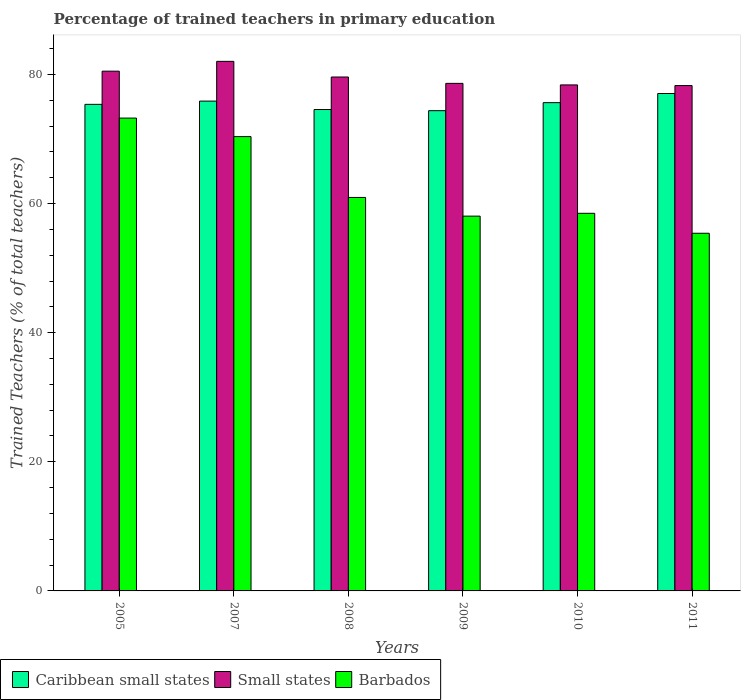How many different coloured bars are there?
Give a very brief answer. 3. How many groups of bars are there?
Keep it short and to the point. 6. Are the number of bars per tick equal to the number of legend labels?
Give a very brief answer. Yes. Are the number of bars on each tick of the X-axis equal?
Your answer should be very brief. Yes. How many bars are there on the 6th tick from the left?
Provide a short and direct response. 3. In how many cases, is the number of bars for a given year not equal to the number of legend labels?
Keep it short and to the point. 0. What is the percentage of trained teachers in Barbados in 2005?
Your answer should be compact. 73.25. Across all years, what is the maximum percentage of trained teachers in Caribbean small states?
Provide a succinct answer. 77.06. Across all years, what is the minimum percentage of trained teachers in Small states?
Keep it short and to the point. 78.28. In which year was the percentage of trained teachers in Barbados maximum?
Provide a succinct answer. 2005. In which year was the percentage of trained teachers in Caribbean small states minimum?
Provide a succinct answer. 2009. What is the total percentage of trained teachers in Caribbean small states in the graph?
Provide a short and direct response. 452.92. What is the difference between the percentage of trained teachers in Small states in 2007 and that in 2009?
Provide a succinct answer. 3.41. What is the difference between the percentage of trained teachers in Barbados in 2005 and the percentage of trained teachers in Small states in 2009?
Your response must be concise. -5.38. What is the average percentage of trained teachers in Caribbean small states per year?
Make the answer very short. 75.49. In the year 2010, what is the difference between the percentage of trained teachers in Barbados and percentage of trained teachers in Caribbean small states?
Give a very brief answer. -17.14. In how many years, is the percentage of trained teachers in Small states greater than 20 %?
Make the answer very short. 6. What is the ratio of the percentage of trained teachers in Caribbean small states in 2005 to that in 2009?
Your answer should be compact. 1.01. Is the difference between the percentage of trained teachers in Barbados in 2007 and 2008 greater than the difference between the percentage of trained teachers in Caribbean small states in 2007 and 2008?
Your answer should be compact. Yes. What is the difference between the highest and the second highest percentage of trained teachers in Caribbean small states?
Your answer should be very brief. 1.18. What is the difference between the highest and the lowest percentage of trained teachers in Barbados?
Provide a succinct answer. 17.84. What does the 1st bar from the left in 2007 represents?
Your answer should be very brief. Caribbean small states. What does the 3rd bar from the right in 2009 represents?
Provide a succinct answer. Caribbean small states. Is it the case that in every year, the sum of the percentage of trained teachers in Small states and percentage of trained teachers in Barbados is greater than the percentage of trained teachers in Caribbean small states?
Your response must be concise. Yes. Are the values on the major ticks of Y-axis written in scientific E-notation?
Keep it short and to the point. No. Does the graph contain any zero values?
Ensure brevity in your answer.  No. Does the graph contain grids?
Your answer should be very brief. No. How many legend labels are there?
Make the answer very short. 3. How are the legend labels stacked?
Keep it short and to the point. Horizontal. What is the title of the graph?
Give a very brief answer. Percentage of trained teachers in primary education. What is the label or title of the X-axis?
Provide a short and direct response. Years. What is the label or title of the Y-axis?
Offer a terse response. Trained Teachers (% of total teachers). What is the Trained Teachers (% of total teachers) of Caribbean small states in 2005?
Give a very brief answer. 75.38. What is the Trained Teachers (% of total teachers) in Small states in 2005?
Ensure brevity in your answer.  80.51. What is the Trained Teachers (% of total teachers) in Barbados in 2005?
Offer a terse response. 73.25. What is the Trained Teachers (% of total teachers) in Caribbean small states in 2007?
Provide a short and direct response. 75.88. What is the Trained Teachers (% of total teachers) of Small states in 2007?
Make the answer very short. 82.04. What is the Trained Teachers (% of total teachers) of Barbados in 2007?
Provide a succinct answer. 70.38. What is the Trained Teachers (% of total teachers) of Caribbean small states in 2008?
Give a very brief answer. 74.57. What is the Trained Teachers (% of total teachers) of Small states in 2008?
Provide a short and direct response. 79.61. What is the Trained Teachers (% of total teachers) of Barbados in 2008?
Keep it short and to the point. 60.95. What is the Trained Teachers (% of total teachers) in Caribbean small states in 2009?
Your answer should be compact. 74.39. What is the Trained Teachers (% of total teachers) of Small states in 2009?
Keep it short and to the point. 78.63. What is the Trained Teachers (% of total teachers) in Barbados in 2009?
Make the answer very short. 58.06. What is the Trained Teachers (% of total teachers) in Caribbean small states in 2010?
Provide a succinct answer. 75.64. What is the Trained Teachers (% of total teachers) of Small states in 2010?
Provide a succinct answer. 78.39. What is the Trained Teachers (% of total teachers) of Barbados in 2010?
Offer a very short reply. 58.5. What is the Trained Teachers (% of total teachers) in Caribbean small states in 2011?
Make the answer very short. 77.06. What is the Trained Teachers (% of total teachers) of Small states in 2011?
Offer a terse response. 78.28. What is the Trained Teachers (% of total teachers) of Barbados in 2011?
Your response must be concise. 55.41. Across all years, what is the maximum Trained Teachers (% of total teachers) of Caribbean small states?
Provide a short and direct response. 77.06. Across all years, what is the maximum Trained Teachers (% of total teachers) in Small states?
Offer a very short reply. 82.04. Across all years, what is the maximum Trained Teachers (% of total teachers) in Barbados?
Give a very brief answer. 73.25. Across all years, what is the minimum Trained Teachers (% of total teachers) of Caribbean small states?
Provide a succinct answer. 74.39. Across all years, what is the minimum Trained Teachers (% of total teachers) of Small states?
Your answer should be compact. 78.28. Across all years, what is the minimum Trained Teachers (% of total teachers) of Barbados?
Keep it short and to the point. 55.41. What is the total Trained Teachers (% of total teachers) in Caribbean small states in the graph?
Keep it short and to the point. 452.92. What is the total Trained Teachers (% of total teachers) in Small states in the graph?
Keep it short and to the point. 477.46. What is the total Trained Teachers (% of total teachers) in Barbados in the graph?
Provide a short and direct response. 376.54. What is the difference between the Trained Teachers (% of total teachers) of Caribbean small states in 2005 and that in 2007?
Provide a short and direct response. -0.5. What is the difference between the Trained Teachers (% of total teachers) in Small states in 2005 and that in 2007?
Your answer should be very brief. -1.52. What is the difference between the Trained Teachers (% of total teachers) of Barbados in 2005 and that in 2007?
Give a very brief answer. 2.87. What is the difference between the Trained Teachers (% of total teachers) of Caribbean small states in 2005 and that in 2008?
Ensure brevity in your answer.  0.8. What is the difference between the Trained Teachers (% of total teachers) in Small states in 2005 and that in 2008?
Keep it short and to the point. 0.91. What is the difference between the Trained Teachers (% of total teachers) of Barbados in 2005 and that in 2008?
Your answer should be very brief. 12.29. What is the difference between the Trained Teachers (% of total teachers) of Caribbean small states in 2005 and that in 2009?
Give a very brief answer. 0.98. What is the difference between the Trained Teachers (% of total teachers) in Small states in 2005 and that in 2009?
Make the answer very short. 1.89. What is the difference between the Trained Teachers (% of total teachers) in Barbados in 2005 and that in 2009?
Offer a very short reply. 15.19. What is the difference between the Trained Teachers (% of total teachers) in Caribbean small states in 2005 and that in 2010?
Provide a succinct answer. -0.26. What is the difference between the Trained Teachers (% of total teachers) in Small states in 2005 and that in 2010?
Make the answer very short. 2.13. What is the difference between the Trained Teachers (% of total teachers) of Barbados in 2005 and that in 2010?
Offer a terse response. 14.75. What is the difference between the Trained Teachers (% of total teachers) of Caribbean small states in 2005 and that in 2011?
Provide a succinct answer. -1.68. What is the difference between the Trained Teachers (% of total teachers) of Small states in 2005 and that in 2011?
Provide a short and direct response. 2.23. What is the difference between the Trained Teachers (% of total teachers) in Barbados in 2005 and that in 2011?
Your answer should be compact. 17.84. What is the difference between the Trained Teachers (% of total teachers) of Caribbean small states in 2007 and that in 2008?
Ensure brevity in your answer.  1.3. What is the difference between the Trained Teachers (% of total teachers) of Small states in 2007 and that in 2008?
Make the answer very short. 2.43. What is the difference between the Trained Teachers (% of total teachers) of Barbados in 2007 and that in 2008?
Your answer should be very brief. 9.43. What is the difference between the Trained Teachers (% of total teachers) of Caribbean small states in 2007 and that in 2009?
Offer a very short reply. 1.48. What is the difference between the Trained Teachers (% of total teachers) of Small states in 2007 and that in 2009?
Ensure brevity in your answer.  3.41. What is the difference between the Trained Teachers (% of total teachers) in Barbados in 2007 and that in 2009?
Your response must be concise. 12.32. What is the difference between the Trained Teachers (% of total teachers) in Caribbean small states in 2007 and that in 2010?
Ensure brevity in your answer.  0.24. What is the difference between the Trained Teachers (% of total teachers) in Small states in 2007 and that in 2010?
Keep it short and to the point. 3.65. What is the difference between the Trained Teachers (% of total teachers) in Barbados in 2007 and that in 2010?
Offer a very short reply. 11.88. What is the difference between the Trained Teachers (% of total teachers) in Caribbean small states in 2007 and that in 2011?
Offer a very short reply. -1.18. What is the difference between the Trained Teachers (% of total teachers) of Small states in 2007 and that in 2011?
Provide a short and direct response. 3.75. What is the difference between the Trained Teachers (% of total teachers) of Barbados in 2007 and that in 2011?
Your answer should be compact. 14.97. What is the difference between the Trained Teachers (% of total teachers) in Caribbean small states in 2008 and that in 2009?
Make the answer very short. 0.18. What is the difference between the Trained Teachers (% of total teachers) of Small states in 2008 and that in 2009?
Provide a succinct answer. 0.98. What is the difference between the Trained Teachers (% of total teachers) in Barbados in 2008 and that in 2009?
Ensure brevity in your answer.  2.9. What is the difference between the Trained Teachers (% of total teachers) in Caribbean small states in 2008 and that in 2010?
Your response must be concise. -1.06. What is the difference between the Trained Teachers (% of total teachers) of Small states in 2008 and that in 2010?
Provide a short and direct response. 1.22. What is the difference between the Trained Teachers (% of total teachers) in Barbados in 2008 and that in 2010?
Keep it short and to the point. 2.46. What is the difference between the Trained Teachers (% of total teachers) in Caribbean small states in 2008 and that in 2011?
Offer a very short reply. -2.48. What is the difference between the Trained Teachers (% of total teachers) of Small states in 2008 and that in 2011?
Offer a very short reply. 1.33. What is the difference between the Trained Teachers (% of total teachers) of Barbados in 2008 and that in 2011?
Give a very brief answer. 5.55. What is the difference between the Trained Teachers (% of total teachers) of Caribbean small states in 2009 and that in 2010?
Provide a succinct answer. -1.25. What is the difference between the Trained Teachers (% of total teachers) of Small states in 2009 and that in 2010?
Your response must be concise. 0.24. What is the difference between the Trained Teachers (% of total teachers) in Barbados in 2009 and that in 2010?
Offer a terse response. -0.44. What is the difference between the Trained Teachers (% of total teachers) in Caribbean small states in 2009 and that in 2011?
Ensure brevity in your answer.  -2.66. What is the difference between the Trained Teachers (% of total teachers) of Small states in 2009 and that in 2011?
Provide a short and direct response. 0.34. What is the difference between the Trained Teachers (% of total teachers) in Barbados in 2009 and that in 2011?
Keep it short and to the point. 2.65. What is the difference between the Trained Teachers (% of total teachers) in Caribbean small states in 2010 and that in 2011?
Your answer should be very brief. -1.42. What is the difference between the Trained Teachers (% of total teachers) in Small states in 2010 and that in 2011?
Keep it short and to the point. 0.1. What is the difference between the Trained Teachers (% of total teachers) in Barbados in 2010 and that in 2011?
Offer a very short reply. 3.09. What is the difference between the Trained Teachers (% of total teachers) in Caribbean small states in 2005 and the Trained Teachers (% of total teachers) in Small states in 2007?
Keep it short and to the point. -6.66. What is the difference between the Trained Teachers (% of total teachers) of Caribbean small states in 2005 and the Trained Teachers (% of total teachers) of Barbados in 2007?
Provide a short and direct response. 5. What is the difference between the Trained Teachers (% of total teachers) in Small states in 2005 and the Trained Teachers (% of total teachers) in Barbados in 2007?
Provide a succinct answer. 10.13. What is the difference between the Trained Teachers (% of total teachers) in Caribbean small states in 2005 and the Trained Teachers (% of total teachers) in Small states in 2008?
Make the answer very short. -4.23. What is the difference between the Trained Teachers (% of total teachers) of Caribbean small states in 2005 and the Trained Teachers (% of total teachers) of Barbados in 2008?
Your answer should be very brief. 14.42. What is the difference between the Trained Teachers (% of total teachers) of Small states in 2005 and the Trained Teachers (% of total teachers) of Barbados in 2008?
Provide a succinct answer. 19.56. What is the difference between the Trained Teachers (% of total teachers) of Caribbean small states in 2005 and the Trained Teachers (% of total teachers) of Small states in 2009?
Offer a terse response. -3.25. What is the difference between the Trained Teachers (% of total teachers) in Caribbean small states in 2005 and the Trained Teachers (% of total teachers) in Barbados in 2009?
Ensure brevity in your answer.  17.32. What is the difference between the Trained Teachers (% of total teachers) in Small states in 2005 and the Trained Teachers (% of total teachers) in Barbados in 2009?
Provide a succinct answer. 22.46. What is the difference between the Trained Teachers (% of total teachers) of Caribbean small states in 2005 and the Trained Teachers (% of total teachers) of Small states in 2010?
Provide a short and direct response. -3.01. What is the difference between the Trained Teachers (% of total teachers) in Caribbean small states in 2005 and the Trained Teachers (% of total teachers) in Barbados in 2010?
Give a very brief answer. 16.88. What is the difference between the Trained Teachers (% of total teachers) of Small states in 2005 and the Trained Teachers (% of total teachers) of Barbados in 2010?
Keep it short and to the point. 22.02. What is the difference between the Trained Teachers (% of total teachers) in Caribbean small states in 2005 and the Trained Teachers (% of total teachers) in Small states in 2011?
Keep it short and to the point. -2.91. What is the difference between the Trained Teachers (% of total teachers) of Caribbean small states in 2005 and the Trained Teachers (% of total teachers) of Barbados in 2011?
Give a very brief answer. 19.97. What is the difference between the Trained Teachers (% of total teachers) of Small states in 2005 and the Trained Teachers (% of total teachers) of Barbados in 2011?
Ensure brevity in your answer.  25.11. What is the difference between the Trained Teachers (% of total teachers) of Caribbean small states in 2007 and the Trained Teachers (% of total teachers) of Small states in 2008?
Make the answer very short. -3.73. What is the difference between the Trained Teachers (% of total teachers) of Caribbean small states in 2007 and the Trained Teachers (% of total teachers) of Barbados in 2008?
Provide a succinct answer. 14.92. What is the difference between the Trained Teachers (% of total teachers) of Small states in 2007 and the Trained Teachers (% of total teachers) of Barbados in 2008?
Provide a short and direct response. 21.08. What is the difference between the Trained Teachers (% of total teachers) in Caribbean small states in 2007 and the Trained Teachers (% of total teachers) in Small states in 2009?
Provide a succinct answer. -2.75. What is the difference between the Trained Teachers (% of total teachers) of Caribbean small states in 2007 and the Trained Teachers (% of total teachers) of Barbados in 2009?
Give a very brief answer. 17.82. What is the difference between the Trained Teachers (% of total teachers) in Small states in 2007 and the Trained Teachers (% of total teachers) in Barbados in 2009?
Offer a terse response. 23.98. What is the difference between the Trained Teachers (% of total teachers) in Caribbean small states in 2007 and the Trained Teachers (% of total teachers) in Small states in 2010?
Provide a succinct answer. -2.51. What is the difference between the Trained Teachers (% of total teachers) in Caribbean small states in 2007 and the Trained Teachers (% of total teachers) in Barbados in 2010?
Make the answer very short. 17.38. What is the difference between the Trained Teachers (% of total teachers) of Small states in 2007 and the Trained Teachers (% of total teachers) of Barbados in 2010?
Keep it short and to the point. 23.54. What is the difference between the Trained Teachers (% of total teachers) of Caribbean small states in 2007 and the Trained Teachers (% of total teachers) of Small states in 2011?
Provide a succinct answer. -2.41. What is the difference between the Trained Teachers (% of total teachers) in Caribbean small states in 2007 and the Trained Teachers (% of total teachers) in Barbados in 2011?
Offer a terse response. 20.47. What is the difference between the Trained Teachers (% of total teachers) of Small states in 2007 and the Trained Teachers (% of total teachers) of Barbados in 2011?
Offer a very short reply. 26.63. What is the difference between the Trained Teachers (% of total teachers) in Caribbean small states in 2008 and the Trained Teachers (% of total teachers) in Small states in 2009?
Provide a succinct answer. -4.05. What is the difference between the Trained Teachers (% of total teachers) of Caribbean small states in 2008 and the Trained Teachers (% of total teachers) of Barbados in 2009?
Make the answer very short. 16.52. What is the difference between the Trained Teachers (% of total teachers) in Small states in 2008 and the Trained Teachers (% of total teachers) in Barbados in 2009?
Offer a very short reply. 21.55. What is the difference between the Trained Teachers (% of total teachers) in Caribbean small states in 2008 and the Trained Teachers (% of total teachers) in Small states in 2010?
Give a very brief answer. -3.81. What is the difference between the Trained Teachers (% of total teachers) of Caribbean small states in 2008 and the Trained Teachers (% of total teachers) of Barbados in 2010?
Your answer should be very brief. 16.08. What is the difference between the Trained Teachers (% of total teachers) in Small states in 2008 and the Trained Teachers (% of total teachers) in Barbados in 2010?
Provide a succinct answer. 21.11. What is the difference between the Trained Teachers (% of total teachers) of Caribbean small states in 2008 and the Trained Teachers (% of total teachers) of Small states in 2011?
Make the answer very short. -3.71. What is the difference between the Trained Teachers (% of total teachers) in Caribbean small states in 2008 and the Trained Teachers (% of total teachers) in Barbados in 2011?
Provide a succinct answer. 19.17. What is the difference between the Trained Teachers (% of total teachers) in Small states in 2008 and the Trained Teachers (% of total teachers) in Barbados in 2011?
Offer a terse response. 24.2. What is the difference between the Trained Teachers (% of total teachers) of Caribbean small states in 2009 and the Trained Teachers (% of total teachers) of Small states in 2010?
Provide a short and direct response. -3.99. What is the difference between the Trained Teachers (% of total teachers) of Caribbean small states in 2009 and the Trained Teachers (% of total teachers) of Barbados in 2010?
Your response must be concise. 15.9. What is the difference between the Trained Teachers (% of total teachers) of Small states in 2009 and the Trained Teachers (% of total teachers) of Barbados in 2010?
Offer a very short reply. 20.13. What is the difference between the Trained Teachers (% of total teachers) of Caribbean small states in 2009 and the Trained Teachers (% of total teachers) of Small states in 2011?
Provide a short and direct response. -3.89. What is the difference between the Trained Teachers (% of total teachers) of Caribbean small states in 2009 and the Trained Teachers (% of total teachers) of Barbados in 2011?
Provide a succinct answer. 18.99. What is the difference between the Trained Teachers (% of total teachers) of Small states in 2009 and the Trained Teachers (% of total teachers) of Barbados in 2011?
Offer a terse response. 23.22. What is the difference between the Trained Teachers (% of total teachers) in Caribbean small states in 2010 and the Trained Teachers (% of total teachers) in Small states in 2011?
Your answer should be compact. -2.64. What is the difference between the Trained Teachers (% of total teachers) of Caribbean small states in 2010 and the Trained Teachers (% of total teachers) of Barbados in 2011?
Keep it short and to the point. 20.23. What is the difference between the Trained Teachers (% of total teachers) in Small states in 2010 and the Trained Teachers (% of total teachers) in Barbados in 2011?
Offer a very short reply. 22.98. What is the average Trained Teachers (% of total teachers) in Caribbean small states per year?
Your response must be concise. 75.49. What is the average Trained Teachers (% of total teachers) of Small states per year?
Offer a very short reply. 79.58. What is the average Trained Teachers (% of total teachers) in Barbados per year?
Give a very brief answer. 62.76. In the year 2005, what is the difference between the Trained Teachers (% of total teachers) in Caribbean small states and Trained Teachers (% of total teachers) in Small states?
Ensure brevity in your answer.  -5.14. In the year 2005, what is the difference between the Trained Teachers (% of total teachers) of Caribbean small states and Trained Teachers (% of total teachers) of Barbados?
Your answer should be compact. 2.13. In the year 2005, what is the difference between the Trained Teachers (% of total teachers) of Small states and Trained Teachers (% of total teachers) of Barbados?
Offer a very short reply. 7.27. In the year 2007, what is the difference between the Trained Teachers (% of total teachers) of Caribbean small states and Trained Teachers (% of total teachers) of Small states?
Provide a succinct answer. -6.16. In the year 2007, what is the difference between the Trained Teachers (% of total teachers) of Caribbean small states and Trained Teachers (% of total teachers) of Barbados?
Offer a terse response. 5.5. In the year 2007, what is the difference between the Trained Teachers (% of total teachers) in Small states and Trained Teachers (% of total teachers) in Barbados?
Ensure brevity in your answer.  11.66. In the year 2008, what is the difference between the Trained Teachers (% of total teachers) in Caribbean small states and Trained Teachers (% of total teachers) in Small states?
Provide a short and direct response. -5.04. In the year 2008, what is the difference between the Trained Teachers (% of total teachers) of Caribbean small states and Trained Teachers (% of total teachers) of Barbados?
Your response must be concise. 13.62. In the year 2008, what is the difference between the Trained Teachers (% of total teachers) of Small states and Trained Teachers (% of total teachers) of Barbados?
Give a very brief answer. 18.66. In the year 2009, what is the difference between the Trained Teachers (% of total teachers) of Caribbean small states and Trained Teachers (% of total teachers) of Small states?
Make the answer very short. -4.23. In the year 2009, what is the difference between the Trained Teachers (% of total teachers) of Caribbean small states and Trained Teachers (% of total teachers) of Barbados?
Keep it short and to the point. 16.34. In the year 2009, what is the difference between the Trained Teachers (% of total teachers) in Small states and Trained Teachers (% of total teachers) in Barbados?
Ensure brevity in your answer.  20.57. In the year 2010, what is the difference between the Trained Teachers (% of total teachers) of Caribbean small states and Trained Teachers (% of total teachers) of Small states?
Offer a terse response. -2.75. In the year 2010, what is the difference between the Trained Teachers (% of total teachers) in Caribbean small states and Trained Teachers (% of total teachers) in Barbados?
Your answer should be compact. 17.14. In the year 2010, what is the difference between the Trained Teachers (% of total teachers) of Small states and Trained Teachers (% of total teachers) of Barbados?
Keep it short and to the point. 19.89. In the year 2011, what is the difference between the Trained Teachers (% of total teachers) in Caribbean small states and Trained Teachers (% of total teachers) in Small states?
Provide a short and direct response. -1.23. In the year 2011, what is the difference between the Trained Teachers (% of total teachers) of Caribbean small states and Trained Teachers (% of total teachers) of Barbados?
Your answer should be compact. 21.65. In the year 2011, what is the difference between the Trained Teachers (% of total teachers) of Small states and Trained Teachers (% of total teachers) of Barbados?
Your response must be concise. 22.88. What is the ratio of the Trained Teachers (% of total teachers) in Small states in 2005 to that in 2007?
Your answer should be very brief. 0.98. What is the ratio of the Trained Teachers (% of total teachers) of Barbados in 2005 to that in 2007?
Give a very brief answer. 1.04. What is the ratio of the Trained Teachers (% of total teachers) of Caribbean small states in 2005 to that in 2008?
Keep it short and to the point. 1.01. What is the ratio of the Trained Teachers (% of total teachers) of Small states in 2005 to that in 2008?
Offer a very short reply. 1.01. What is the ratio of the Trained Teachers (% of total teachers) of Barbados in 2005 to that in 2008?
Keep it short and to the point. 1.2. What is the ratio of the Trained Teachers (% of total teachers) of Caribbean small states in 2005 to that in 2009?
Keep it short and to the point. 1.01. What is the ratio of the Trained Teachers (% of total teachers) in Barbados in 2005 to that in 2009?
Offer a very short reply. 1.26. What is the ratio of the Trained Teachers (% of total teachers) in Small states in 2005 to that in 2010?
Your answer should be compact. 1.03. What is the ratio of the Trained Teachers (% of total teachers) in Barbados in 2005 to that in 2010?
Ensure brevity in your answer.  1.25. What is the ratio of the Trained Teachers (% of total teachers) in Caribbean small states in 2005 to that in 2011?
Make the answer very short. 0.98. What is the ratio of the Trained Teachers (% of total teachers) of Small states in 2005 to that in 2011?
Give a very brief answer. 1.03. What is the ratio of the Trained Teachers (% of total teachers) in Barbados in 2005 to that in 2011?
Offer a terse response. 1.32. What is the ratio of the Trained Teachers (% of total teachers) in Caribbean small states in 2007 to that in 2008?
Ensure brevity in your answer.  1.02. What is the ratio of the Trained Teachers (% of total teachers) in Small states in 2007 to that in 2008?
Provide a short and direct response. 1.03. What is the ratio of the Trained Teachers (% of total teachers) of Barbados in 2007 to that in 2008?
Ensure brevity in your answer.  1.15. What is the ratio of the Trained Teachers (% of total teachers) of Caribbean small states in 2007 to that in 2009?
Make the answer very short. 1.02. What is the ratio of the Trained Teachers (% of total teachers) of Small states in 2007 to that in 2009?
Give a very brief answer. 1.04. What is the ratio of the Trained Teachers (% of total teachers) of Barbados in 2007 to that in 2009?
Provide a short and direct response. 1.21. What is the ratio of the Trained Teachers (% of total teachers) in Small states in 2007 to that in 2010?
Make the answer very short. 1.05. What is the ratio of the Trained Teachers (% of total teachers) of Barbados in 2007 to that in 2010?
Keep it short and to the point. 1.2. What is the ratio of the Trained Teachers (% of total teachers) of Caribbean small states in 2007 to that in 2011?
Offer a terse response. 0.98. What is the ratio of the Trained Teachers (% of total teachers) of Small states in 2007 to that in 2011?
Give a very brief answer. 1.05. What is the ratio of the Trained Teachers (% of total teachers) of Barbados in 2007 to that in 2011?
Your answer should be very brief. 1.27. What is the ratio of the Trained Teachers (% of total teachers) in Caribbean small states in 2008 to that in 2009?
Offer a terse response. 1. What is the ratio of the Trained Teachers (% of total teachers) in Small states in 2008 to that in 2009?
Your answer should be compact. 1.01. What is the ratio of the Trained Teachers (% of total teachers) of Barbados in 2008 to that in 2009?
Make the answer very short. 1.05. What is the ratio of the Trained Teachers (% of total teachers) in Caribbean small states in 2008 to that in 2010?
Provide a succinct answer. 0.99. What is the ratio of the Trained Teachers (% of total teachers) of Small states in 2008 to that in 2010?
Offer a terse response. 1.02. What is the ratio of the Trained Teachers (% of total teachers) of Barbados in 2008 to that in 2010?
Give a very brief answer. 1.04. What is the ratio of the Trained Teachers (% of total teachers) in Caribbean small states in 2008 to that in 2011?
Give a very brief answer. 0.97. What is the ratio of the Trained Teachers (% of total teachers) in Small states in 2008 to that in 2011?
Your answer should be compact. 1.02. What is the ratio of the Trained Teachers (% of total teachers) in Barbados in 2008 to that in 2011?
Give a very brief answer. 1.1. What is the ratio of the Trained Teachers (% of total teachers) of Caribbean small states in 2009 to that in 2010?
Give a very brief answer. 0.98. What is the ratio of the Trained Teachers (% of total teachers) of Small states in 2009 to that in 2010?
Offer a very short reply. 1. What is the ratio of the Trained Teachers (% of total teachers) in Caribbean small states in 2009 to that in 2011?
Provide a short and direct response. 0.97. What is the ratio of the Trained Teachers (% of total teachers) in Barbados in 2009 to that in 2011?
Provide a succinct answer. 1.05. What is the ratio of the Trained Teachers (% of total teachers) of Caribbean small states in 2010 to that in 2011?
Your answer should be very brief. 0.98. What is the ratio of the Trained Teachers (% of total teachers) in Barbados in 2010 to that in 2011?
Your answer should be very brief. 1.06. What is the difference between the highest and the second highest Trained Teachers (% of total teachers) of Caribbean small states?
Provide a short and direct response. 1.18. What is the difference between the highest and the second highest Trained Teachers (% of total teachers) in Small states?
Your answer should be very brief. 1.52. What is the difference between the highest and the second highest Trained Teachers (% of total teachers) in Barbados?
Make the answer very short. 2.87. What is the difference between the highest and the lowest Trained Teachers (% of total teachers) of Caribbean small states?
Provide a short and direct response. 2.66. What is the difference between the highest and the lowest Trained Teachers (% of total teachers) of Small states?
Offer a very short reply. 3.75. What is the difference between the highest and the lowest Trained Teachers (% of total teachers) of Barbados?
Your response must be concise. 17.84. 